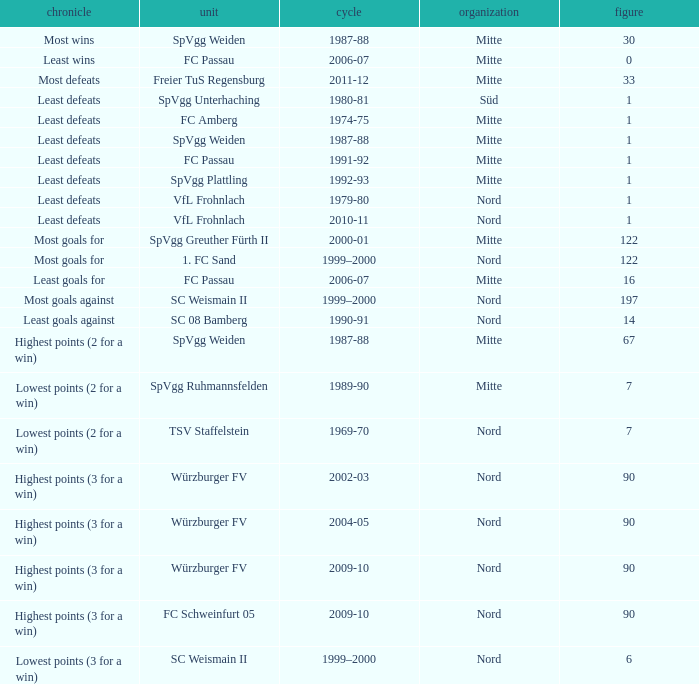What team has 2000-01 as the season? SpVgg Greuther Fürth II. 